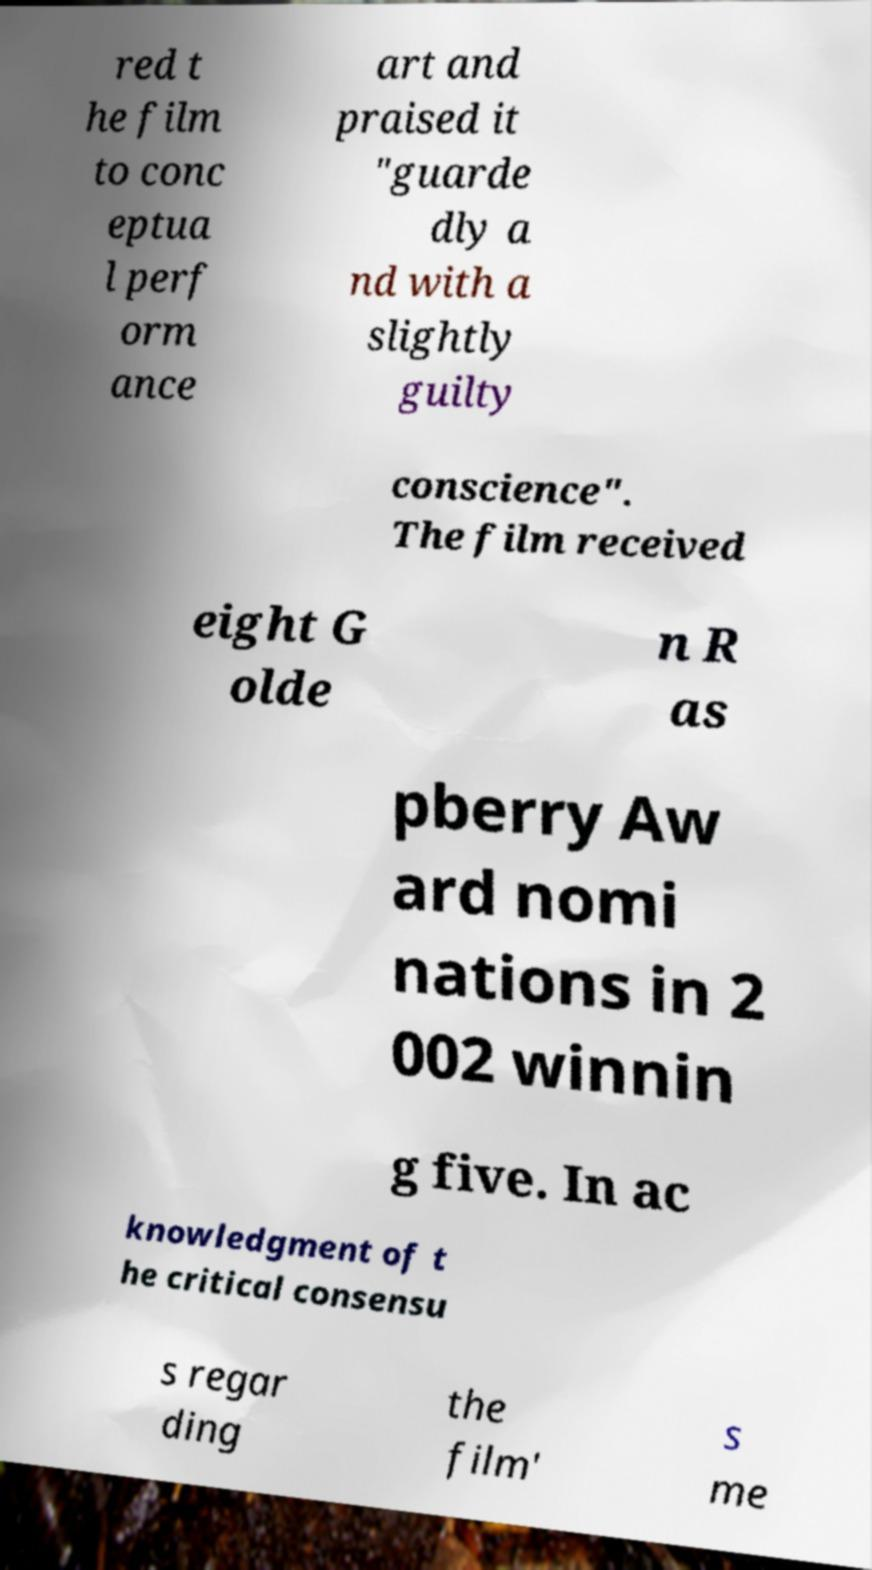Could you assist in decoding the text presented in this image and type it out clearly? red t he film to conc eptua l perf orm ance art and praised it "guarde dly a nd with a slightly guilty conscience". The film received eight G olde n R as pberry Aw ard nomi nations in 2 002 winnin g five. In ac knowledgment of t he critical consensu s regar ding the film' s me 